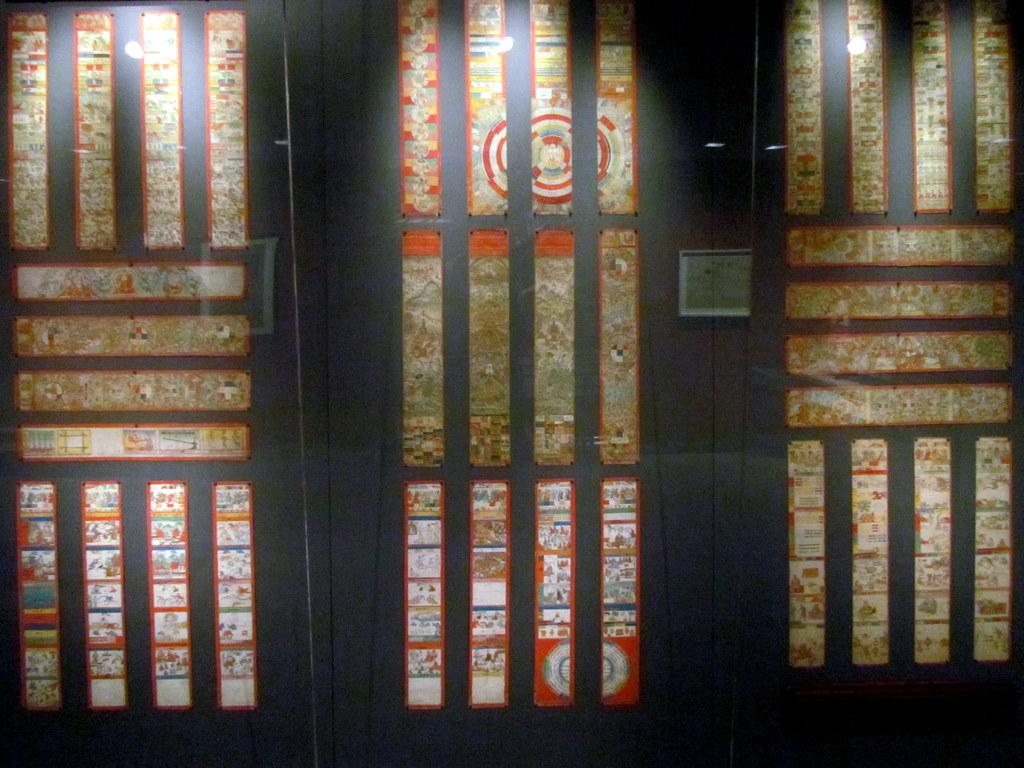How many windows are visible in the image? There are three windows in the image. What scent can be detected coming from the windows in the image? There is no information about scents in the image, as it only mentions the presence of three windows. 